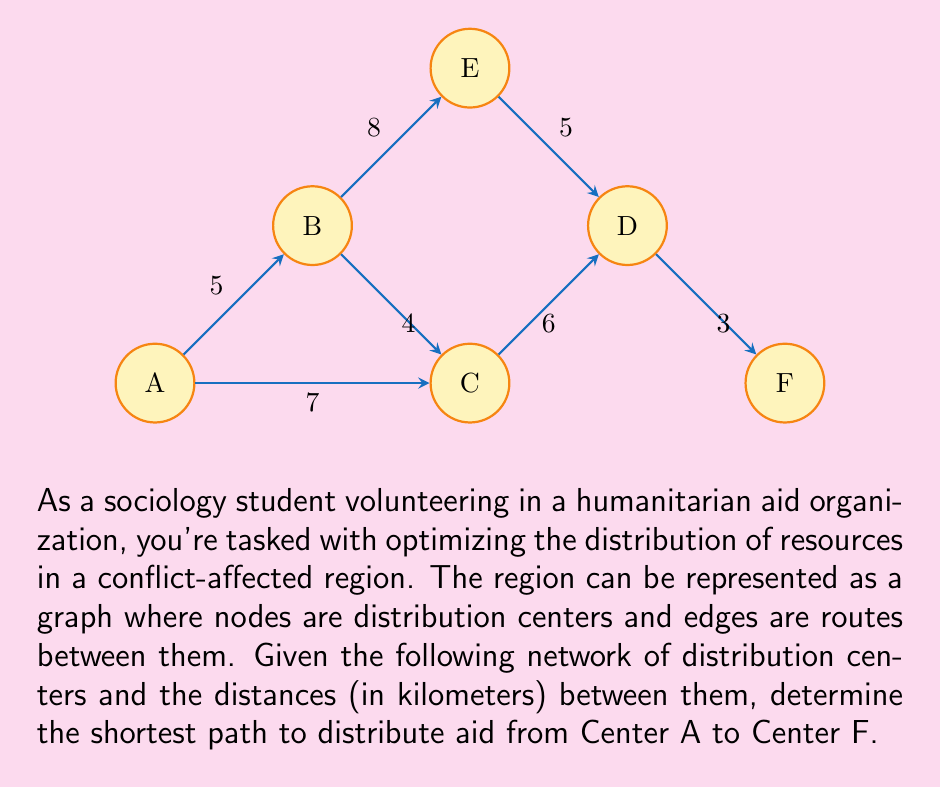Provide a solution to this math problem. To solve this problem, we'll use Dijkstra's algorithm, which is an efficient method for finding the shortest path between nodes in a graph.

Step 1: Initialize distances
Set the distance to A as 0 and all other nodes as infinity.
$d(A) = 0$, $d(B) = d(C) = d(D) = d(E) = d(F) = \infty$

Step 2: Visit node A
Update distances to neighbors:
$d(B) = \min(\infty, 0 + 5) = 5$
$d(C) = \min(\infty, 0 + 7) = 7$

Step 3: Visit node B (closest unvisited node)
Update distances:
$d(C) = \min(7, 5 + 4) = 7$ (no change)
$d(E) = \min(\infty, 5 + 8) = 13$

Step 4: Visit node C
Update distances:
$d(D) = \min(\infty, 7 + 6) = 13$

Step 5: Visit node D
Update distances:
$d(E) = \min(13, 13 + 5) = 13$ (no change)
$d(F) = \min(\infty, 13 + 3) = 16$

Step 6: Visit node E (no updates needed)

Step 7: Visit node F (final node)

The shortest path from A to F is A → C → D → F with a total distance of 16 km.
Answer: A → C → D → F, 16 km 